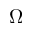<formula> <loc_0><loc_0><loc_500><loc_500>\Omega</formula> 